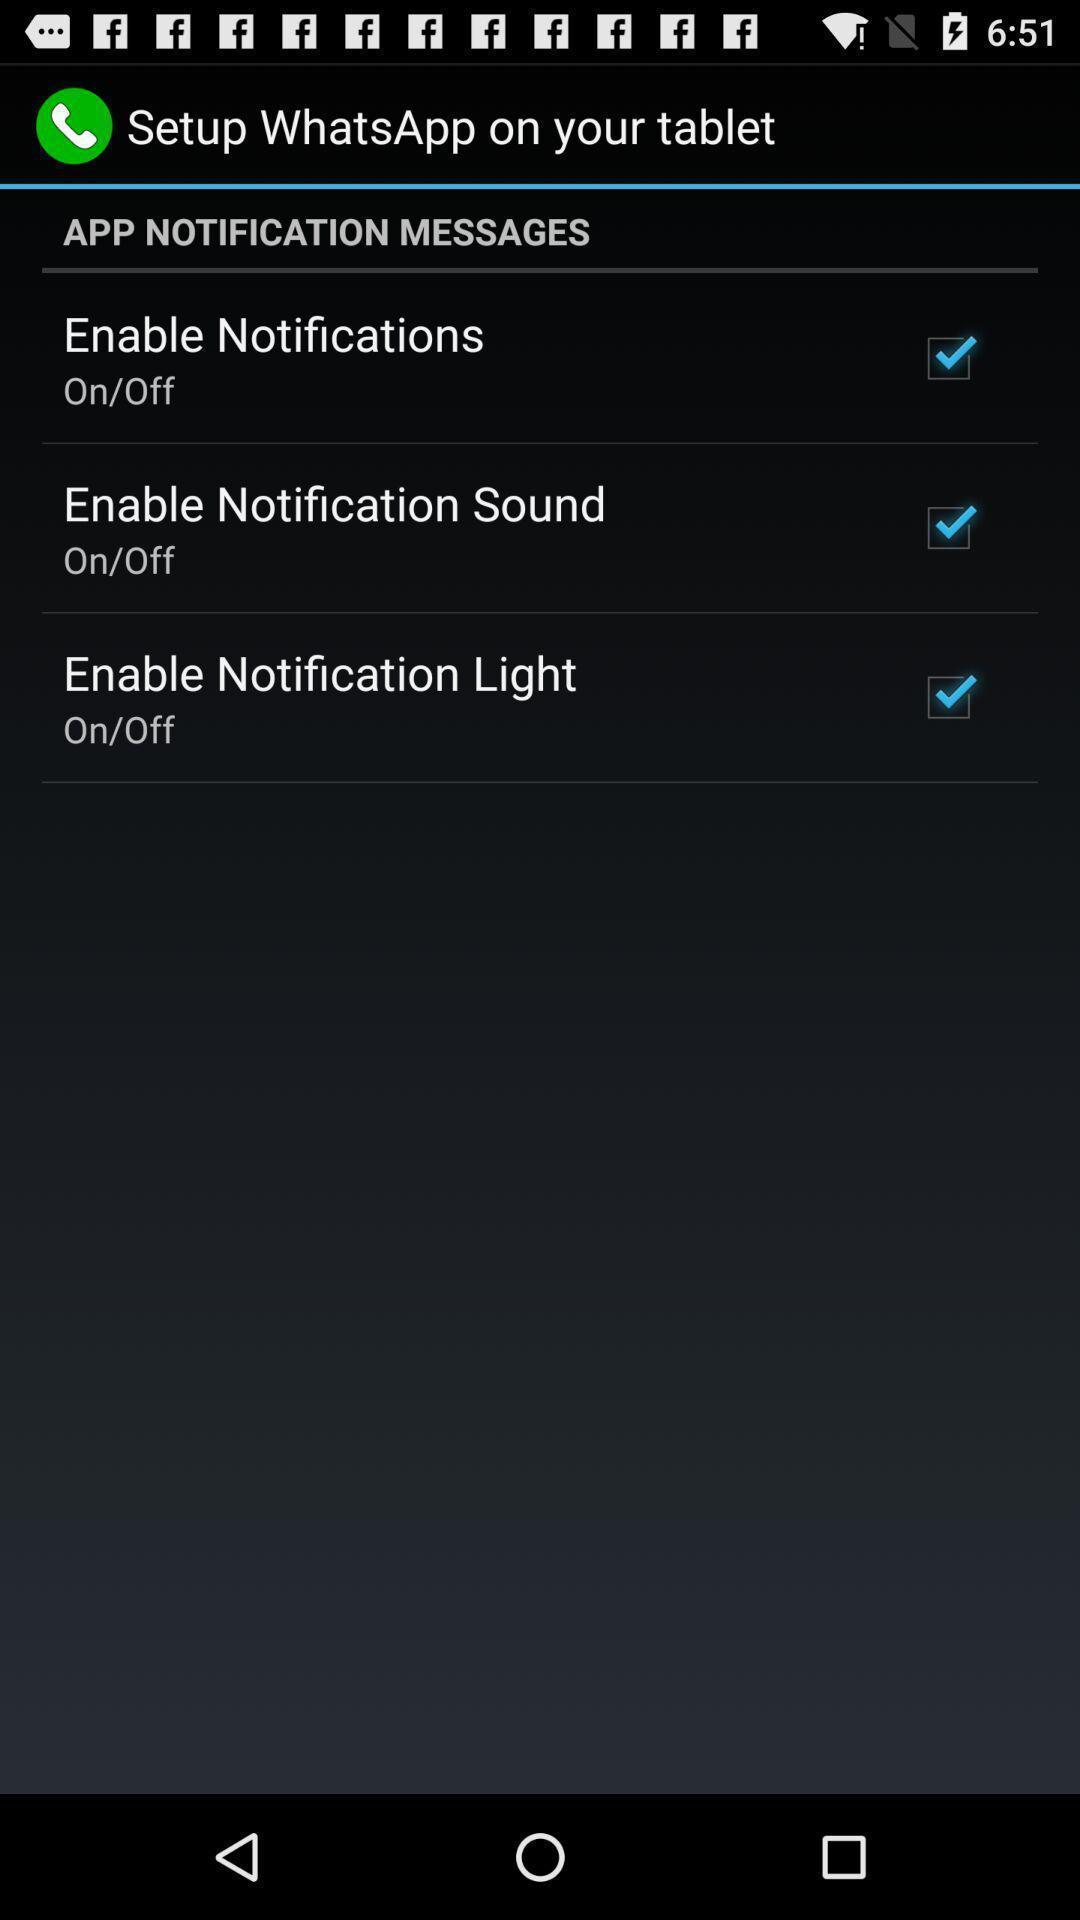What details can you identify in this image? Setting up in a device. 